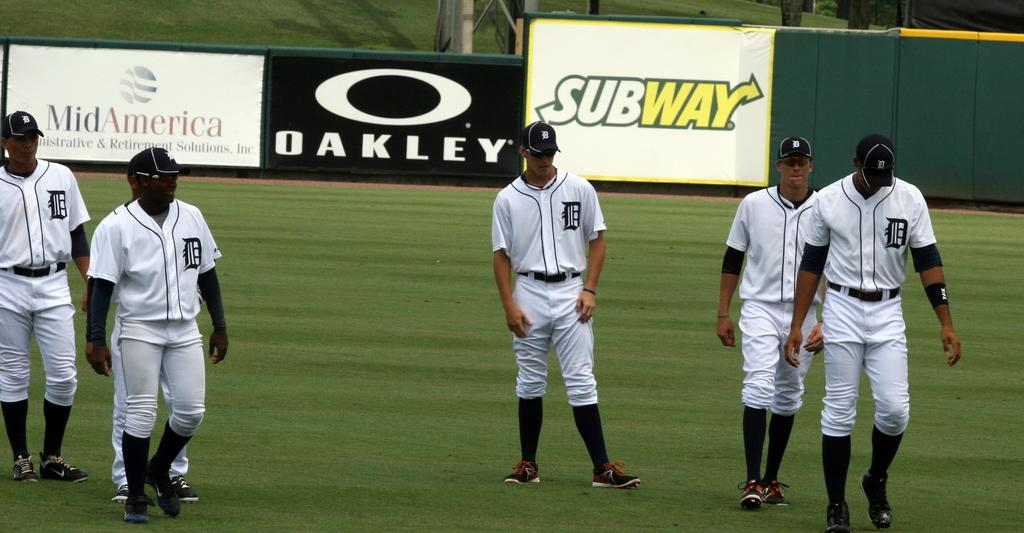<image>
Render a clear and concise summary of the photo. A group of baseball players wearing Detroit uniforms on a baseball field. 